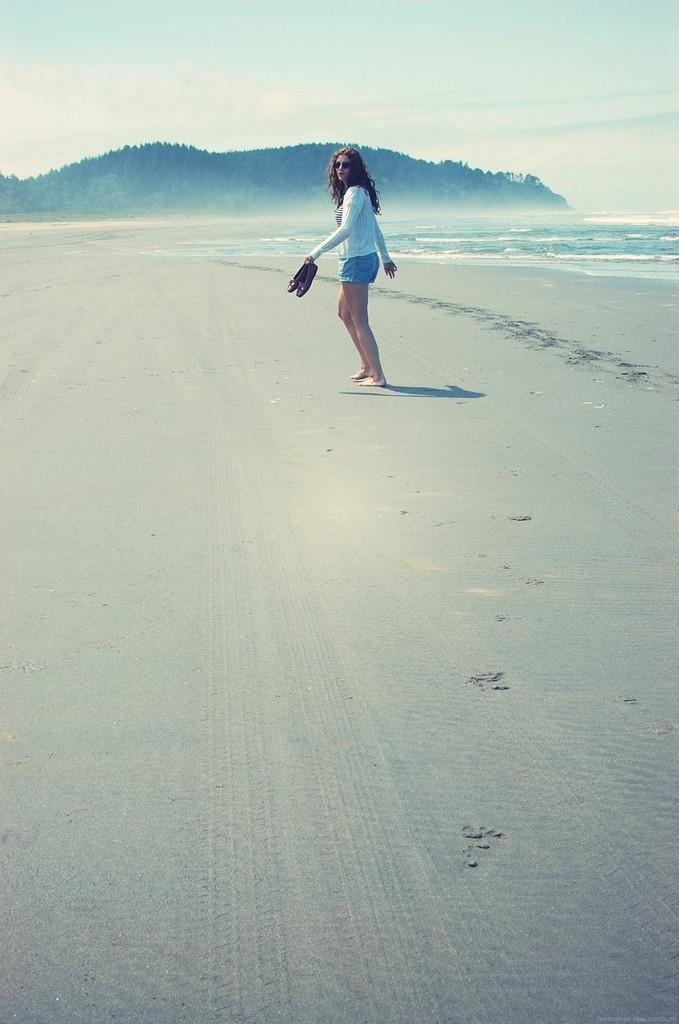Who is the main subject in the image? There is a girl in the image. What is the girl doing in the image? The girl is walking on the seashore. What is the girl holding in the image? The girl is holding shoes. What can be seen in the background of the image? There is a mountain in the image, and it has many trees. Where is the crate located in the image? There is no crate present in the image. What is the girl doing in the middle of the image? The girl is walking on the seashore, and her position in the image cannot be determined as "middle" without more information about the image's composition. 